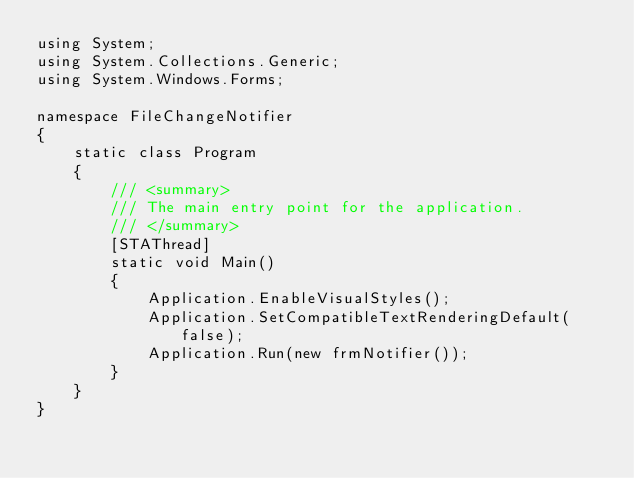Convert code to text. <code><loc_0><loc_0><loc_500><loc_500><_C#_>using System;
using System.Collections.Generic;
using System.Windows.Forms;

namespace FileChangeNotifier
{
    static class Program
    {
        /// <summary>
        /// The main entry point for the application.
        /// </summary>
        [STAThread]
        static void Main()
        {
            Application.EnableVisualStyles();
            Application.SetCompatibleTextRenderingDefault(false);
            Application.Run(new frmNotifier());
        }
    }
}</code> 